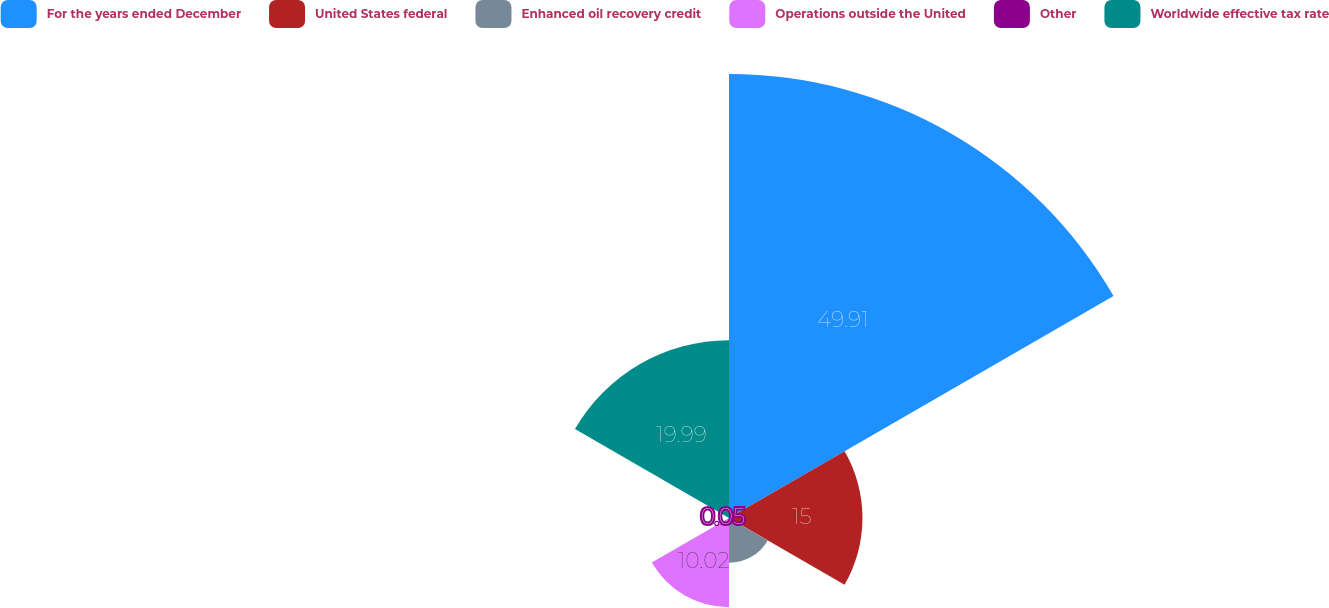Convert chart. <chart><loc_0><loc_0><loc_500><loc_500><pie_chart><fcel>For the years ended December<fcel>United States federal<fcel>Enhanced oil recovery credit<fcel>Operations outside the United<fcel>Other<fcel>Worldwide effective tax rate<nl><fcel>49.9%<fcel>15.0%<fcel>5.03%<fcel>10.02%<fcel>0.05%<fcel>19.99%<nl></chart> 